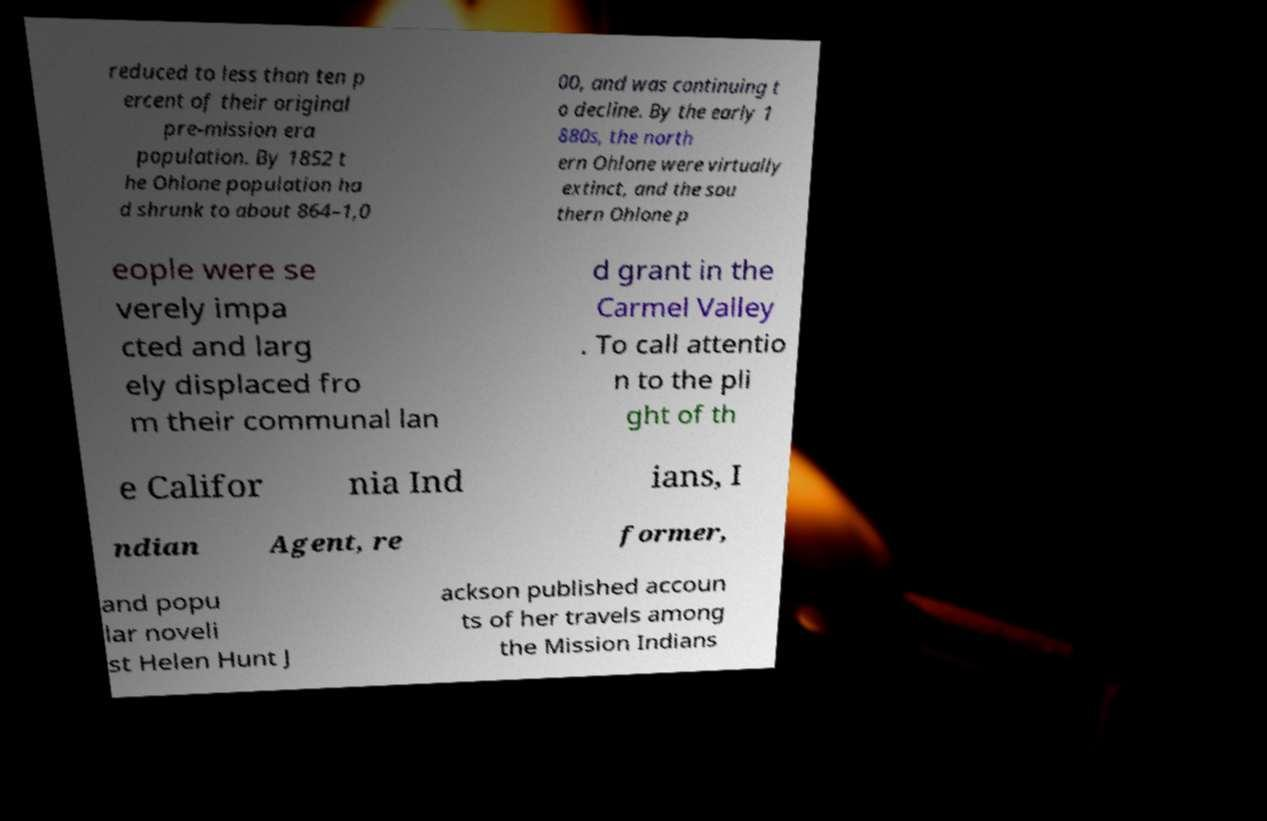For documentation purposes, I need the text within this image transcribed. Could you provide that? reduced to less than ten p ercent of their original pre-mission era population. By 1852 t he Ohlone population ha d shrunk to about 864–1,0 00, and was continuing t o decline. By the early 1 880s, the north ern Ohlone were virtually extinct, and the sou thern Ohlone p eople were se verely impa cted and larg ely displaced fro m their communal lan d grant in the Carmel Valley . To call attentio n to the pli ght of th e Califor nia Ind ians, I ndian Agent, re former, and popu lar noveli st Helen Hunt J ackson published accoun ts of her travels among the Mission Indians 